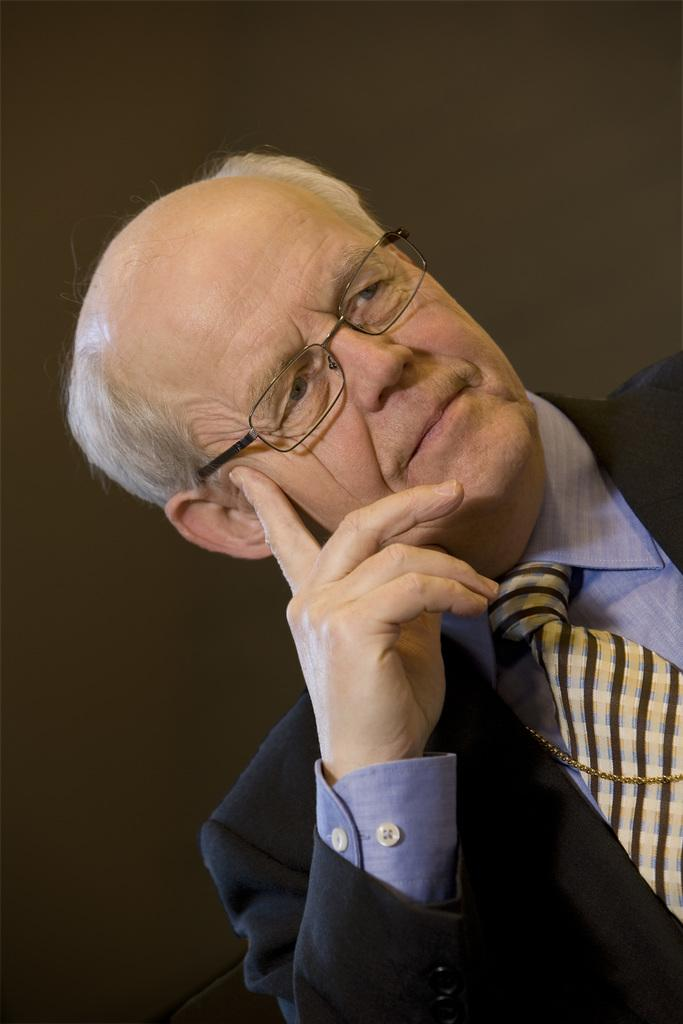Who is the main subject in the image? There is an old man in the image. What is the old man wearing? The old man is wearing a suit, a shirt, and a tie. What can be observed about the background of the image? The background of the image is dark. How many grapes can be seen on the old man's tie in the image? There are no grapes present on the old man's tie in the image. What type of frog is sitting on the old man's shoulder in the image? There is no frog present on the old man's shoulder in the image. 